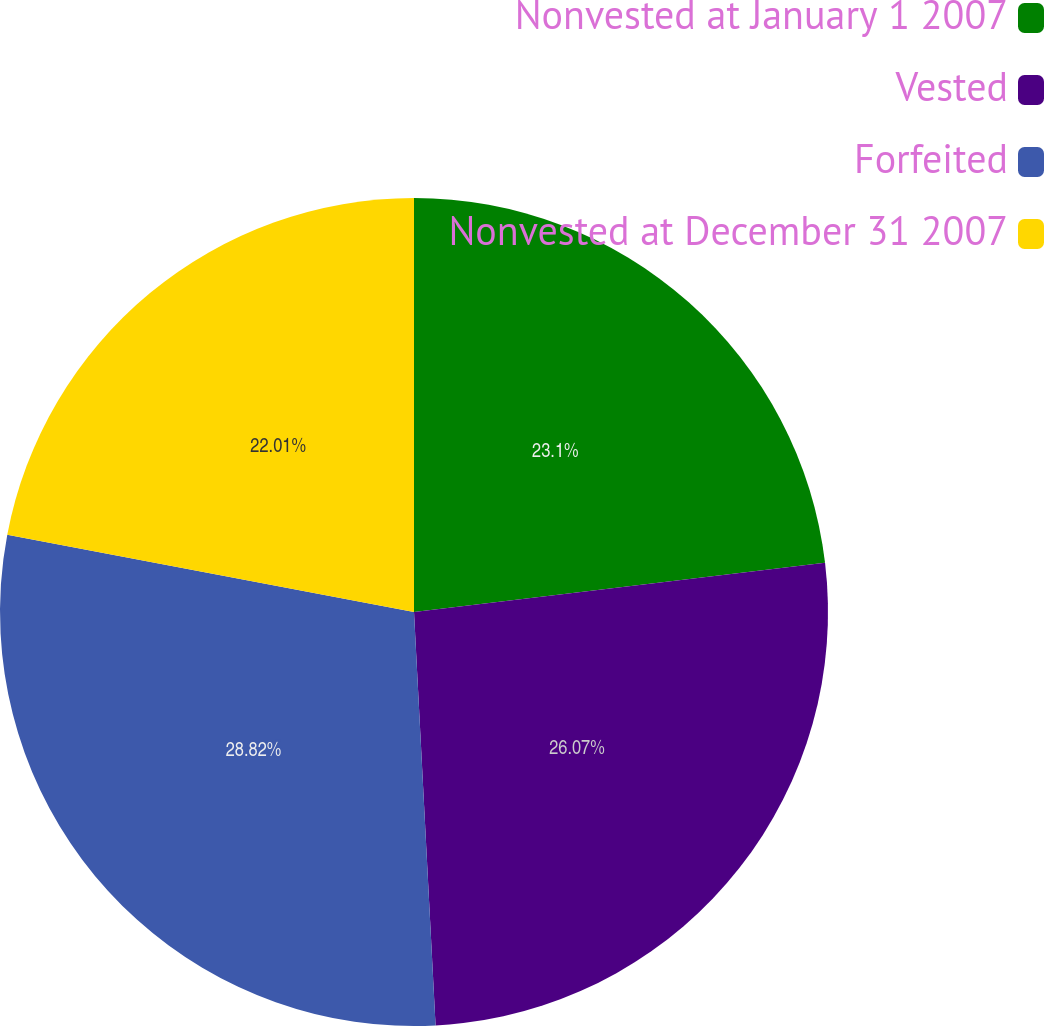Convert chart. <chart><loc_0><loc_0><loc_500><loc_500><pie_chart><fcel>Nonvested at January 1 2007<fcel>Vested<fcel>Forfeited<fcel>Nonvested at December 31 2007<nl><fcel>23.1%<fcel>26.07%<fcel>28.82%<fcel>22.01%<nl></chart> 